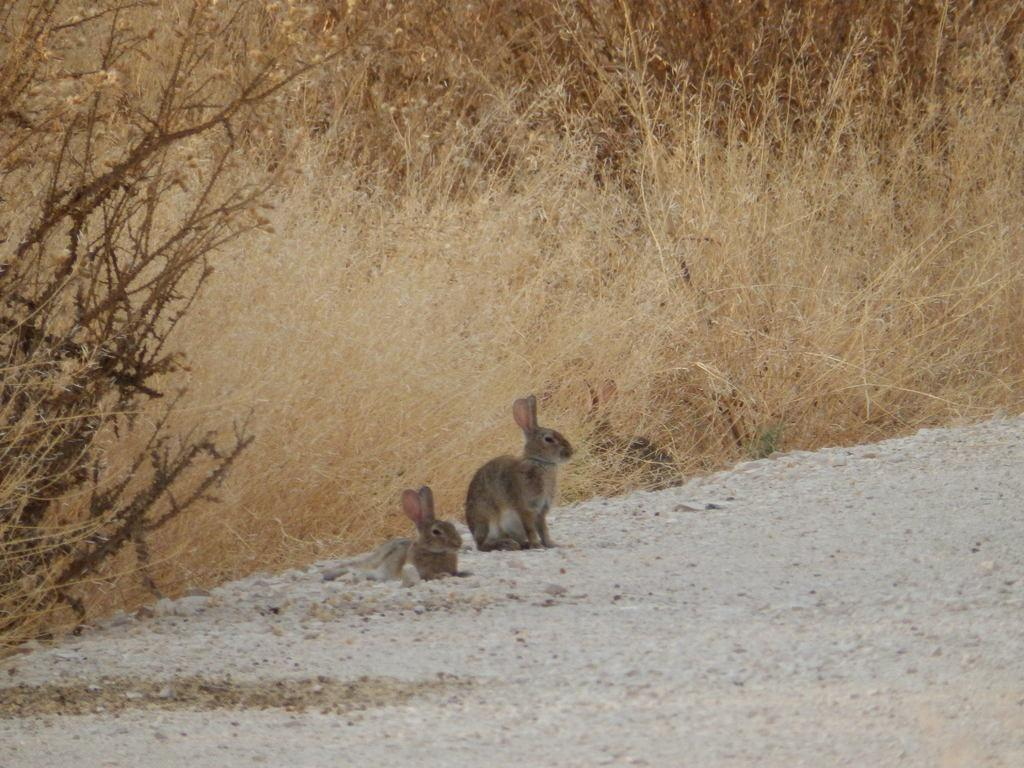What type of animals can be seen in the image? There are rabbits in the image. What type of terrain is visible in the image? There is sand and dried grass in the image. What type of vegetation is present in the image? There are trees in the image. Can you see any fairies flying around the rabbits in the image? No, there are no fairies present in the image. What type of toy can be seen in the image? There is no toy present in the image. 